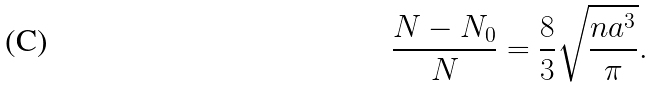<formula> <loc_0><loc_0><loc_500><loc_500>\frac { N - N _ { 0 } } { N } = \frac { 8 } { 3 } \sqrt { \frac { n a ^ { 3 } } { \pi } } .</formula> 